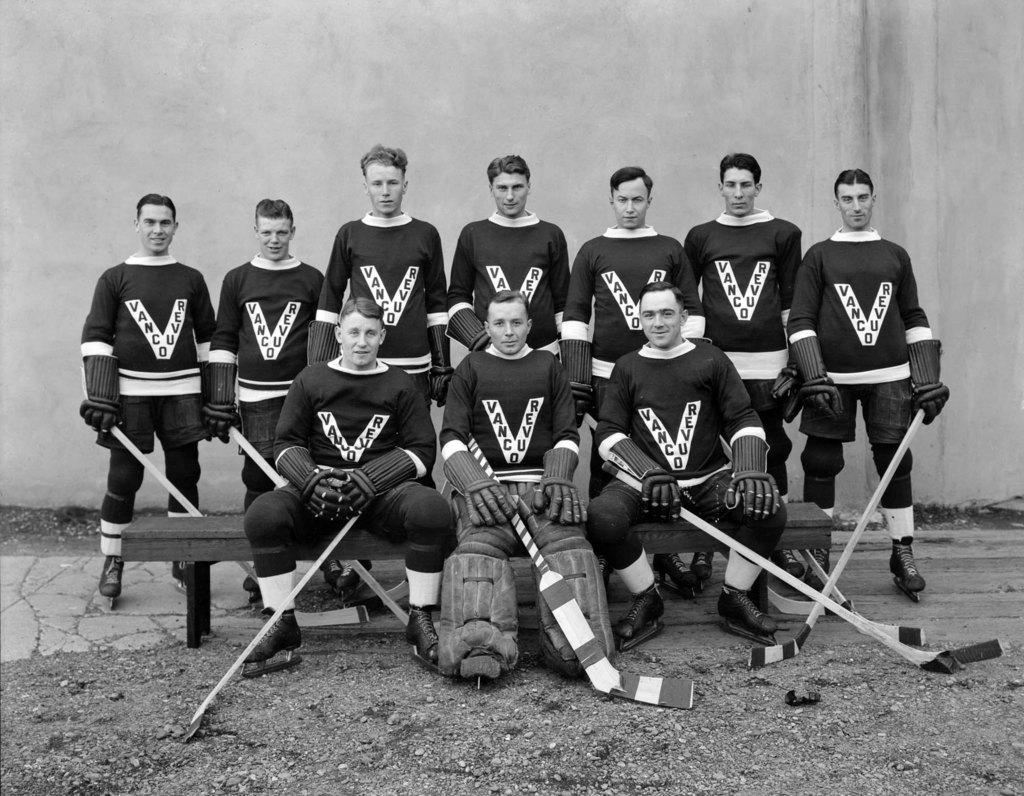<image>
Describe the image concisely. The vancouver hockey team all standing together with their hockey sticks. 